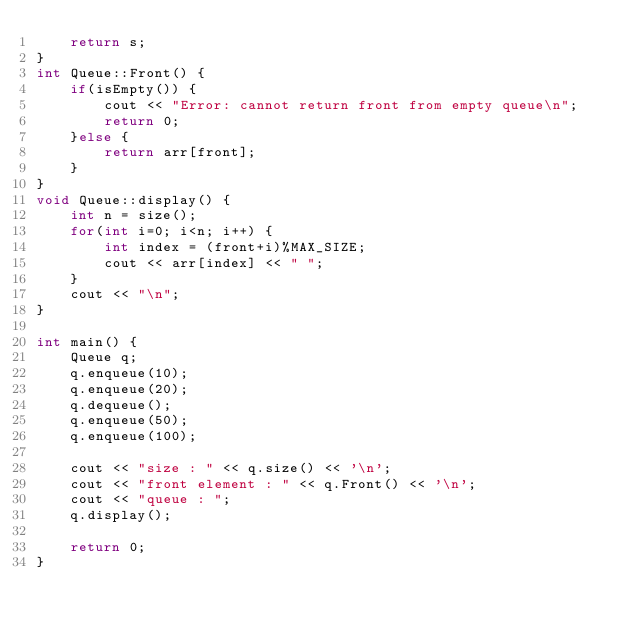Convert code to text. <code><loc_0><loc_0><loc_500><loc_500><_C++_>    return s;
}
int Queue::Front() {
    if(isEmpty()) {
        cout << "Error: cannot return front from empty queue\n";
        return 0;
    }else {
        return arr[front];
    }
}
void Queue::display() {
    int n = size();
    for(int i=0; i<n; i++) {
        int index = (front+i)%MAX_SIZE;
        cout << arr[index] << " ";
    }
    cout << "\n";
}

int main() {
    Queue q;
    q.enqueue(10);
    q.enqueue(20);
    q.dequeue();
    q.enqueue(50);
    q.enqueue(100);

    cout << "size : " << q.size() << '\n';
    cout << "front element : " << q.Front() << '\n';
    cout << "queue : "; 
    q.display();

    return 0;
}
</code> 